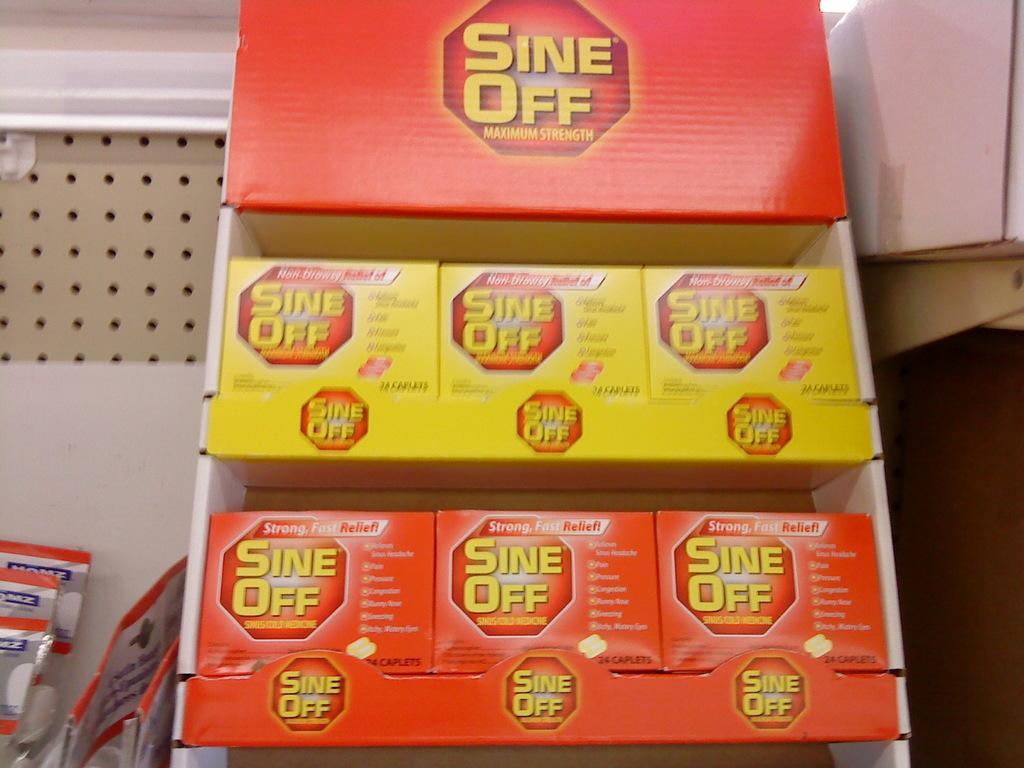Could you give a brief overview of what you see in this image? There are boxes arranged on the shelves. In the background, there are packets in a white wall. 